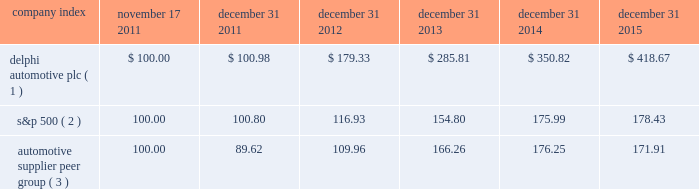Table of contents stock performance graph * $ 100 invested on 11/17/11 in our stock or 10/31/11 in the relevant index , including reinvestment of dividends .
Fiscal year ending december 31 , 2015 .
( 1 ) delphi automotive plc ( 2 ) s&p 500 2013 standard & poor 2019s 500 total return index ( 3 ) automotive supplier peer group 2013 russell 3000 auto parts index , including american axle & manufacturing , borgwarner inc. , cooper tire & rubber company , dana holding corp. , delphi automotive plc , dorman products inc. , federal-mogul corp. , ford motor co. , fuel systems solutions inc. , general motors co. , gentex corp. , gentherm inc. , genuine parts co. , johnson controls inc. , lear corp. , lkq corp. , meritor inc. , standard motor products inc. , stoneridge inc. , superior industries international , tenneco inc. , tesla motors inc. , the goodyear tire & rubber co. , tower international inc. , visteon corp. , and wabco holdings inc .
Company index november 17 , december 31 , december 31 , december 31 , december 31 , december 31 .
Dividends the company has declared and paid cash dividends of $ 0.25 per ordinary share in each quarter of 2014 and 2015 .
In addition , in january 2016 , the board of directors increased the annual dividend rate to $ 1.16 per ordinary share , and declared a regular quarterly cash dividend of $ 0.29 per ordinary share , payable on february 29 , 2016 to shareholders of record at the close of business on february 17 , 2016. .
What is the difference in total return on delphi automotive plc and the automotive supplier peer group for the five year period ending december 31 2015? 
Computations: (((418.67 - 100) / 100) - ((171.91 - 100) / 100))
Answer: 2.4676. 